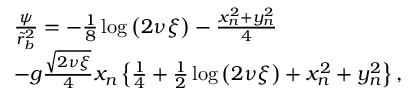<formula> <loc_0><loc_0><loc_500><loc_500>\begin{array} { r l } & { \frac { \psi } { \tilde { r } _ { b } ^ { 2 } } = - \frac { 1 } { 8 } \log \left ( 2 \nu \xi \right ) - \frac { x _ { n } ^ { 2 } + y _ { n } ^ { 2 } } { 4 } } \\ & { - g \frac { \sqrt { 2 \nu \xi } } { 4 } x _ { n } \left \{ \frac { 1 } { 4 } + \frac { 1 } { 2 } \log \left ( 2 \nu \xi \right ) + x _ { n } ^ { 2 } + y _ { n } ^ { 2 } \right \} , } \end{array}</formula> 